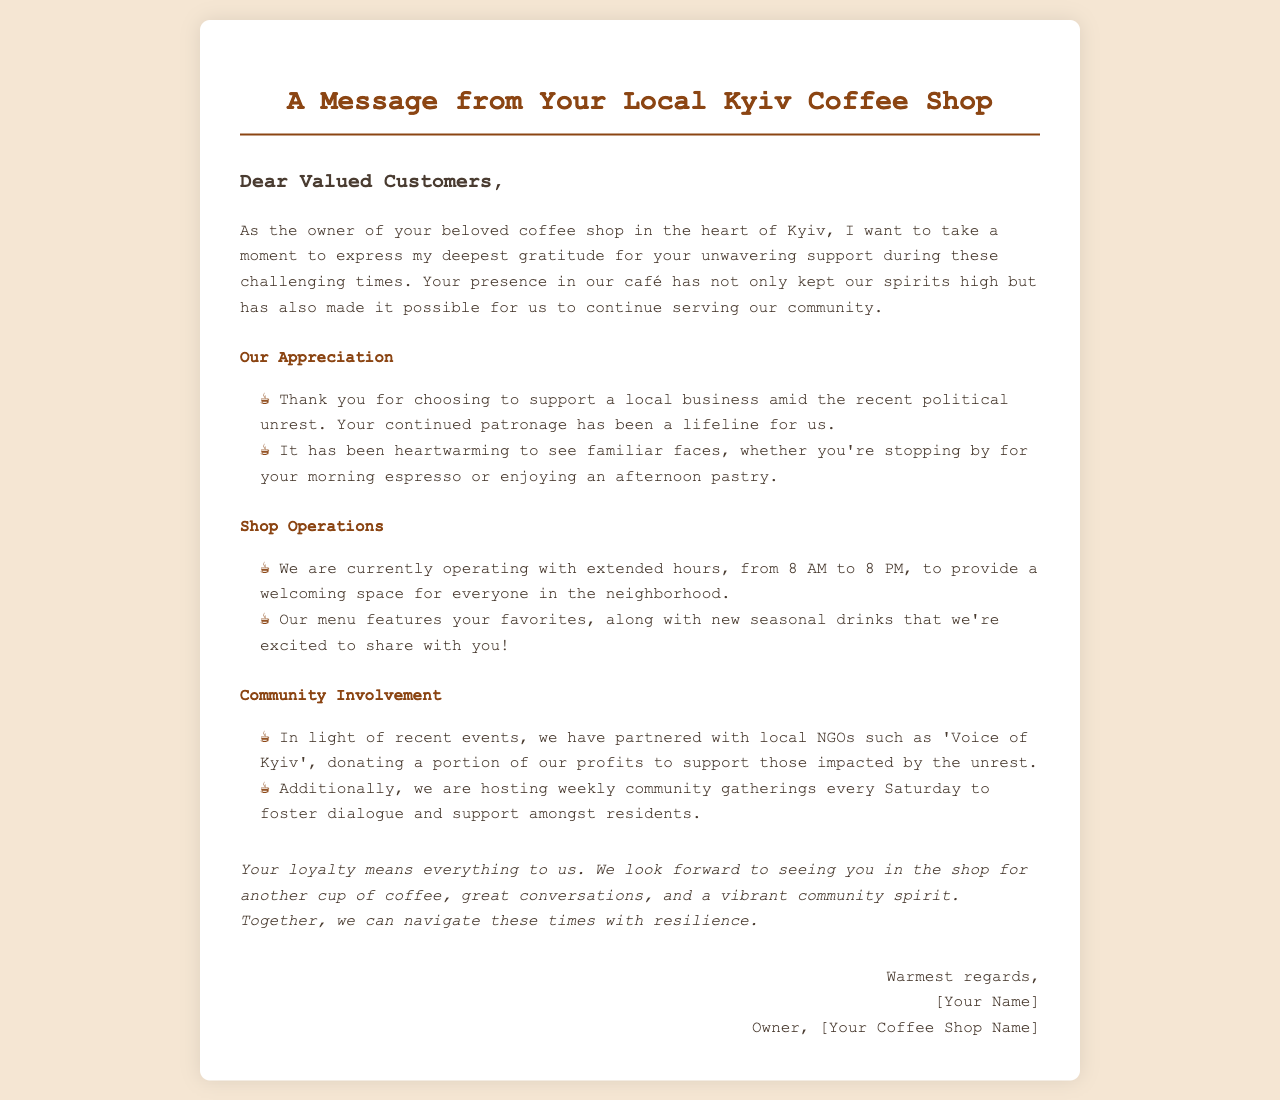What is the coffee shop's current operating hours? The hours of operation are mentioned in the document, which states the shop is open from 8 AM to 8 PM.
Answer: 8 AM to 8 PM Who is the owner of the coffee shop? The document includes a closing section where the owner's name is listed.
Answer: [Your Name] What community effort is the coffee shop involved in? The document references the shop's partnership with local NGOs and community gatherings as part of its community involvement.
Answer: Partnered with local NGOs What type of drinks are featured on the menu? The document mentions the presence of favorites along with new seasonal drinks for customers.
Answer: New seasonal drinks When are community gatherings held? The document specifies that the community gatherings take place weekly on Saturdays.
Answer: Every Saturday How does the coffee shop express its gratitude? The document outlines specific acknowledgments of customer support and loyal patronage during challenging times.
Answer: Thank you for choosing to support a local business What is the intended atmosphere of the coffee shop during the unrest? The document discusses creating a welcoming space for everyone in the neighborhood.
Answer: Welcoming space What emotion is conveyed by the owner towards the customers? The letter expresses a deep sense of appreciation and gratitude for the customers' support.
Answer: Gratitude What was included in the letter's closing remarks? The closing remarks highlight the importance of customer loyalty and encourage the community spirit.
Answer: Your loyalty means everything to us 